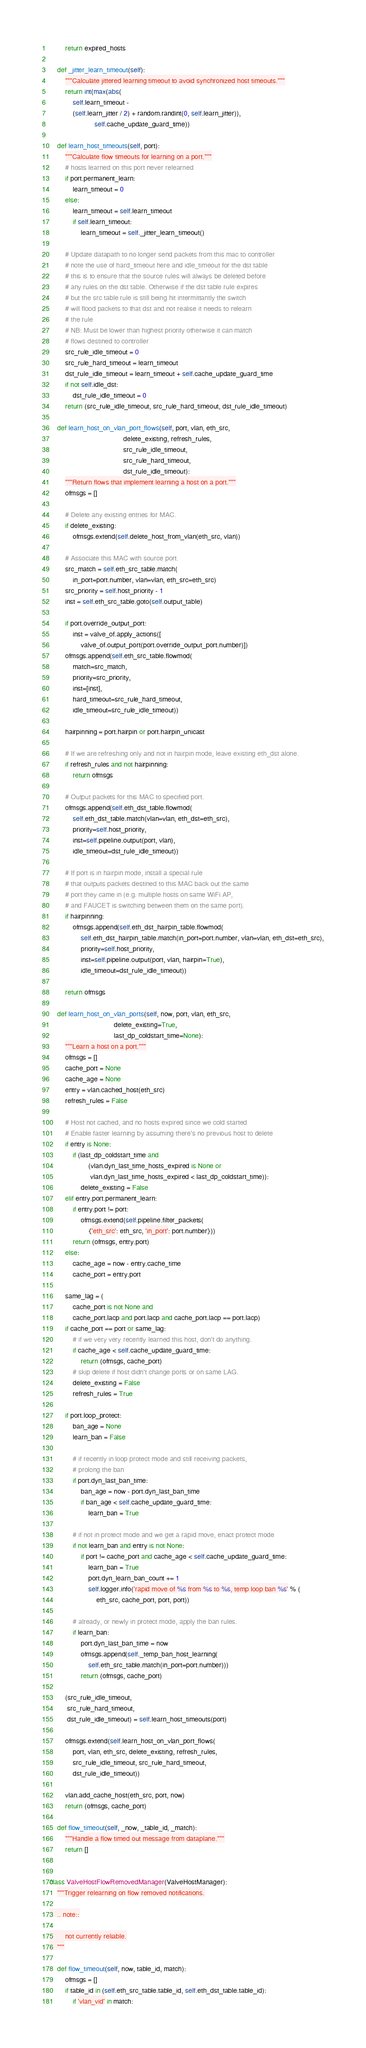Convert code to text. <code><loc_0><loc_0><loc_500><loc_500><_Python_>        return expired_hosts

    def _jitter_learn_timeout(self):
        """Calculate jittered learning timeout to avoid synchronized host timeouts."""
        return int(max(abs(
            self.learn_timeout -
            (self.learn_jitter / 2) + random.randint(0, self.learn_jitter)),
                       self.cache_update_guard_time))

    def learn_host_timeouts(self, port):
        """Calculate flow timeouts for learning on a port."""
        # hosts learned on this port never relearned
        if port.permanent_learn:
            learn_timeout = 0
        else:
            learn_timeout = self.learn_timeout
            if self.learn_timeout:
                learn_timeout = self._jitter_learn_timeout()

        # Update datapath to no longer send packets from this mac to controller
        # note the use of hard_timeout here and idle_timeout for the dst table
        # this is to ensure that the source rules will always be deleted before
        # any rules on the dst table. Otherwise if the dst table rule expires
        # but the src table rule is still being hit intermittantly the switch
        # will flood packets to that dst and not realise it needs to relearn
        # the rule
        # NB: Must be lower than highest priority otherwise it can match
        # flows destined to controller
        src_rule_idle_timeout = 0
        src_rule_hard_timeout = learn_timeout
        dst_rule_idle_timeout = learn_timeout + self.cache_update_guard_time
        if not self.idle_dst:
            dst_rule_idle_timeout = 0
        return (src_rule_idle_timeout, src_rule_hard_timeout, dst_rule_idle_timeout)

    def learn_host_on_vlan_port_flows(self, port, vlan, eth_src,
                                      delete_existing, refresh_rules,
                                      src_rule_idle_timeout,
                                      src_rule_hard_timeout,
                                      dst_rule_idle_timeout):
        """Return flows that implement learning a host on a port."""
        ofmsgs = []

        # Delete any existing entries for MAC.
        if delete_existing:
            ofmsgs.extend(self.delete_host_from_vlan(eth_src, vlan))

        # Associate this MAC with source port.
        src_match = self.eth_src_table.match(
            in_port=port.number, vlan=vlan, eth_src=eth_src)
        src_priority = self.host_priority - 1
        inst = self.eth_src_table.goto(self.output_table)

        if port.override_output_port:
            inst = valve_of.apply_actions([
                valve_of.output_port(port.override_output_port.number)])
        ofmsgs.append(self.eth_src_table.flowmod(
            match=src_match,
            priority=src_priority,
            inst=[inst],
            hard_timeout=src_rule_hard_timeout,
            idle_timeout=src_rule_idle_timeout))

        hairpinning = port.hairpin or port.hairpin_unicast

        # If we are refreshing only and not in hairpin mode, leave existing eth_dst alone.
        if refresh_rules and not hairpinning:
            return ofmsgs

        # Output packets for this MAC to specified port.
        ofmsgs.append(self.eth_dst_table.flowmod(
            self.eth_dst_table.match(vlan=vlan, eth_dst=eth_src),
            priority=self.host_priority,
            inst=self.pipeline.output(port, vlan),
            idle_timeout=dst_rule_idle_timeout))

        # If port is in hairpin mode, install a special rule
        # that outputs packets destined to this MAC back out the same
        # port they came in (e.g. multiple hosts on same WiFi AP,
        # and FAUCET is switching between them on the same port).
        if hairpinning:
            ofmsgs.append(self.eth_dst_hairpin_table.flowmod(
                self.eth_dst_hairpin_table.match(in_port=port.number, vlan=vlan, eth_dst=eth_src),
                priority=self.host_priority,
                inst=self.pipeline.output(port, vlan, hairpin=True),
                idle_timeout=dst_rule_idle_timeout))

        return ofmsgs

    def learn_host_on_vlan_ports(self, now, port, vlan, eth_src,
                                 delete_existing=True,
                                 last_dp_coldstart_time=None):
        """Learn a host on a port."""
        ofmsgs = []
        cache_port = None
        cache_age = None
        entry = vlan.cached_host(eth_src)
        refresh_rules = False

        # Host not cached, and no hosts expired since we cold started
        # Enable faster learning by assuming there's no previous host to delete
        if entry is None:
            if (last_dp_coldstart_time and
                    (vlan.dyn_last_time_hosts_expired is None or
                     vlan.dyn_last_time_hosts_expired < last_dp_coldstart_time)):
                delete_existing = False
        elif entry.port.permanent_learn:
            if entry.port != port:
                ofmsgs.extend(self.pipeline.filter_packets(
                    {'eth_src': eth_src, 'in_port': port.number}))
            return (ofmsgs, entry.port)
        else:
            cache_age = now - entry.cache_time
            cache_port = entry.port

        same_lag = (
            cache_port is not None and
            cache_port.lacp and port.lacp and cache_port.lacp == port.lacp)
        if cache_port == port or same_lag:
            # if we very very recently learned this host, don't do anything.
            if cache_age < self.cache_update_guard_time:
                return (ofmsgs, cache_port)
            # skip delete if host didn't change ports or on same LAG.
            delete_existing = False
            refresh_rules = True

        if port.loop_protect:
            ban_age = None
            learn_ban = False

            # if recently in loop protect mode and still receiving packets,
            # prolong the ban
            if port.dyn_last_ban_time:
                ban_age = now - port.dyn_last_ban_time
                if ban_age < self.cache_update_guard_time:
                    learn_ban = True

            # if not in protect mode and we get a rapid move, enact protect mode
            if not learn_ban and entry is not None:
                if port != cache_port and cache_age < self.cache_update_guard_time:
                    learn_ban = True
                    port.dyn_learn_ban_count += 1
                    self.logger.info('rapid move of %s from %s to %s, temp loop ban %s' % (
                        eth_src, cache_port, port, port))

            # already, or newly in protect mode, apply the ban rules.
            if learn_ban:
                port.dyn_last_ban_time = now
                ofmsgs.append(self._temp_ban_host_learning(
                    self.eth_src_table.match(in_port=port.number)))
                return (ofmsgs, cache_port)

        (src_rule_idle_timeout,
         src_rule_hard_timeout,
         dst_rule_idle_timeout) = self.learn_host_timeouts(port)

        ofmsgs.extend(self.learn_host_on_vlan_port_flows(
            port, vlan, eth_src, delete_existing, refresh_rules,
            src_rule_idle_timeout, src_rule_hard_timeout,
            dst_rule_idle_timeout))

        vlan.add_cache_host(eth_src, port, now)
        return (ofmsgs, cache_port)

    def flow_timeout(self, _now, _table_id, _match):
        """Handle a flow timed out message from dataplane."""
        return []


class ValveHostFlowRemovedManager(ValveHostManager):
    """Trigger relearning on flow removed notifications.

    .. note::

        not currently reliable.
    """

    def flow_timeout(self, now, table_id, match):
        ofmsgs = []
        if table_id in (self.eth_src_table.table_id, self.eth_dst_table.table_id):
            if 'vlan_vid' in match:</code> 